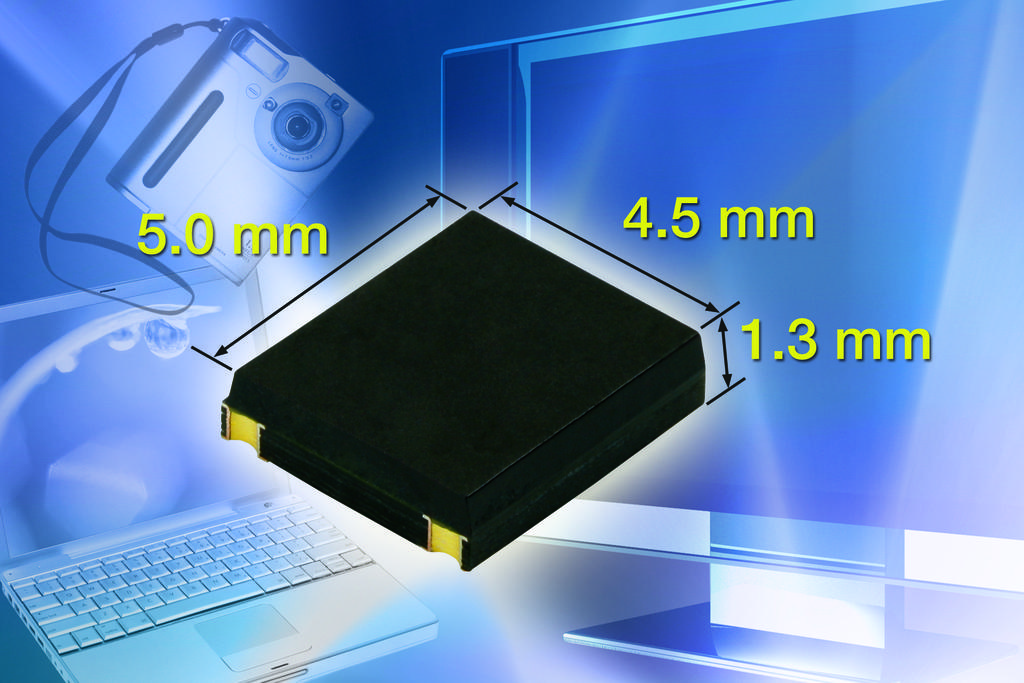How many millimeters is the left side?
Your answer should be compact. 5.0. What is the height of this box?
Make the answer very short. 1.3 mm. 